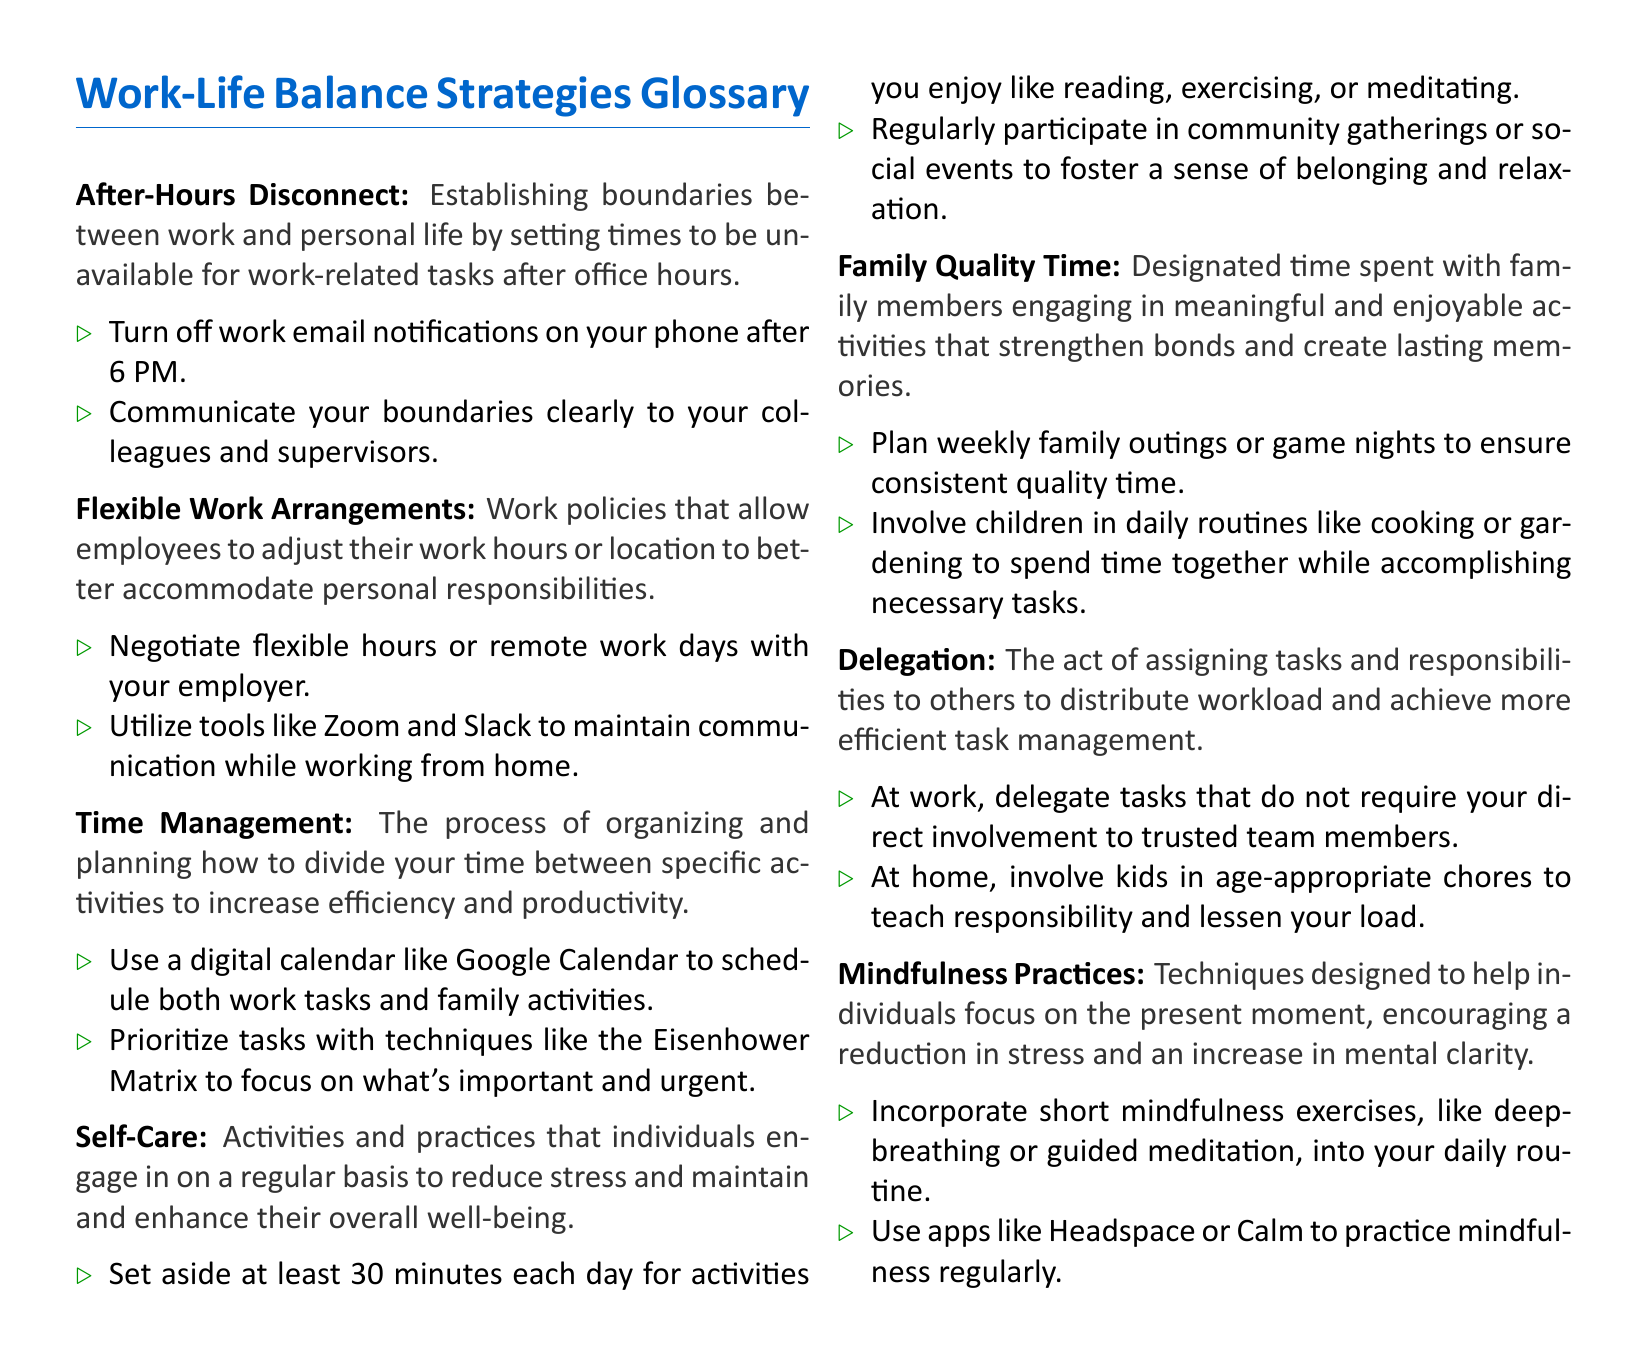What is "After-Hours Disconnect"? "After-Hours Disconnect" is defined as establishing boundaries between work and personal life by setting times to be unavailable for work-related tasks after office hours.
Answer: Establishing boundaries between work and personal life What is a recommended tip for "Self-Care"? The document suggests setting aside at least 30 minutes each day for activities you enjoy like reading, exercising, or meditating as a self-care practice.
Answer: Set aside at least 30 minutes each day What does "Family Quality Time" refer to? "Family Quality Time" refers to designated time spent with family members engaging in meaningful and enjoyable activities that strengthen bonds.
Answer: Designated time spent with family members Which strategy involves assigning tasks to others? The strategy that involves assigning tasks and responsibilities to others is called delegation.
Answer: Delegation What tool is suggested for scheduling? The document suggests using a digital calendar like Google Calendar for scheduling.
Answer: Google Calendar How can mindfulness practices help? Mindfulness practices are designed to help individuals focus on the present moment, reducing stress and increasing mental clarity.
Answer: Reducing stress and increasing mental clarity What is the importance of "Flexible Work Arrangements"? "Flexible Work Arrangements" allow employees to adjust their work hours or location to better accommodate personal responsibilities.
Answer: Adjust work hours or location What is the primary goal of "Time Management"? The primary goal of "Time Management" is to increase efficiency and productivity by organizing and planning how to divide your time between activities.
Answer: Increase efficiency and productivity What is a community-related tip for self-care? A community-related tip for self-care is to regularly participate in community gatherings or social events.
Answer: Participate in community gatherings 